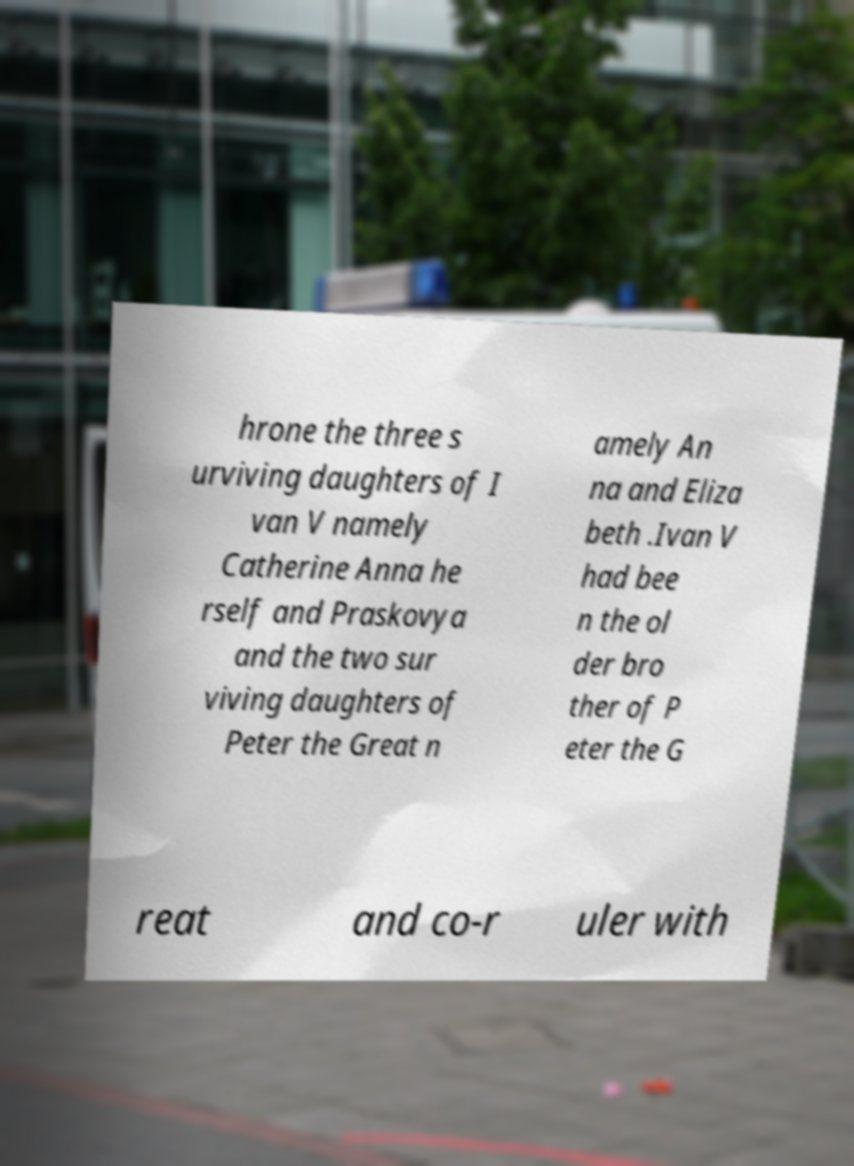There's text embedded in this image that I need extracted. Can you transcribe it verbatim? hrone the three s urviving daughters of I van V namely Catherine Anna he rself and Praskovya and the two sur viving daughters of Peter the Great n amely An na and Eliza beth .Ivan V had bee n the ol der bro ther of P eter the G reat and co-r uler with 